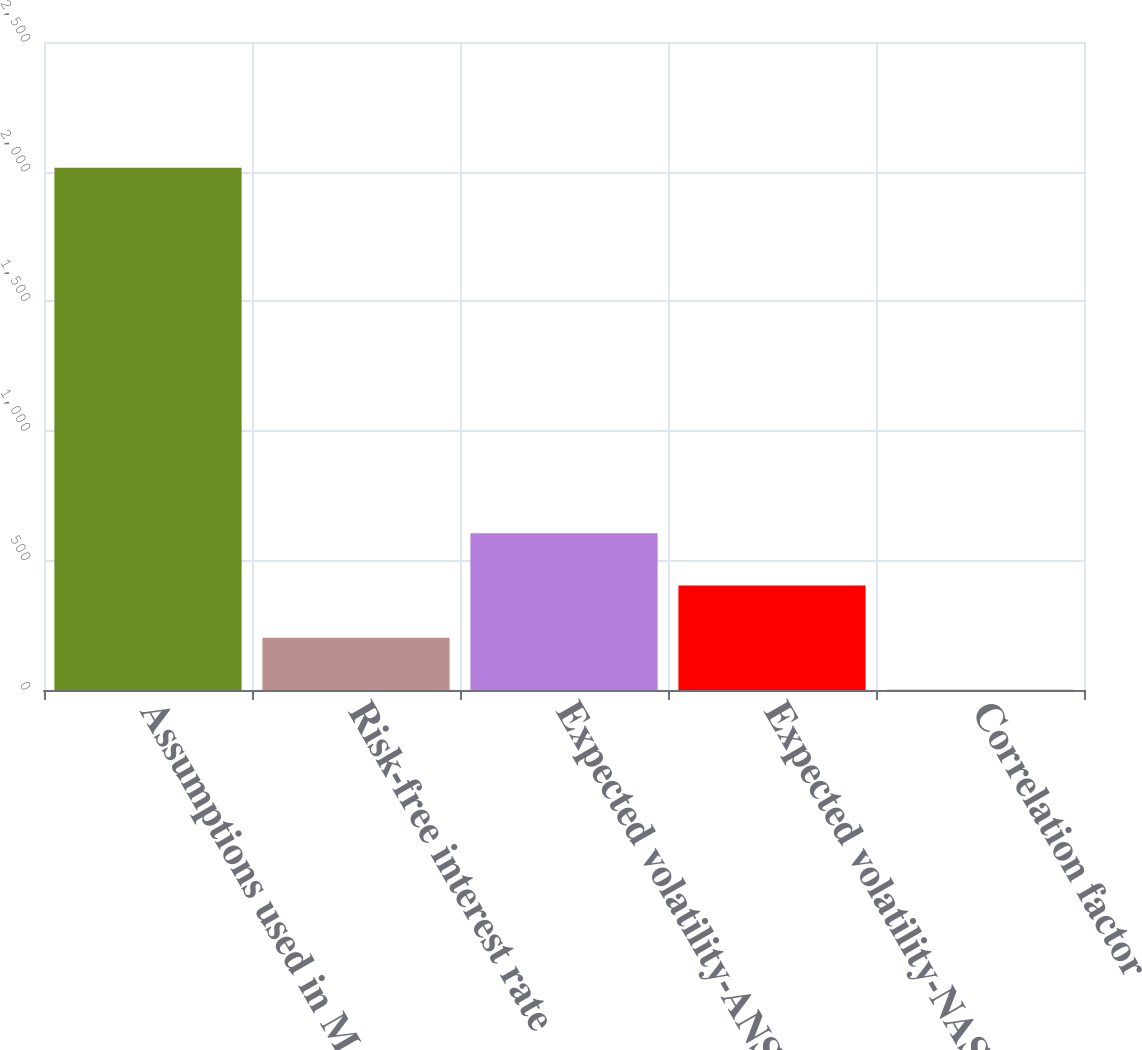Convert chart to OTSL. <chart><loc_0><loc_0><loc_500><loc_500><bar_chart><fcel>Assumptions used in Monte<fcel>Risk-free interest rate<fcel>Expected volatility-ANSYS<fcel>Expected volatility-NASDAQ<fcel>Correlation factor<nl><fcel>2015<fcel>202.04<fcel>604.92<fcel>403.48<fcel>0.6<nl></chart> 